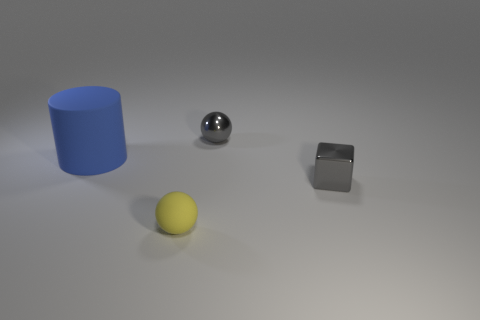What material is the thing that is both to the right of the yellow rubber ball and behind the gray cube?
Provide a short and direct response. Metal. What number of small gray metal things have the same shape as the blue matte thing?
Offer a terse response. 0. What is the sphere that is right of the small yellow thing made of?
Make the answer very short. Metal. Is the number of small gray objects to the right of the tiny yellow thing less than the number of tiny gray metallic objects?
Your response must be concise. No. Is the small matte object the same shape as the blue matte object?
Your response must be concise. No. Is there anything else that is the same shape as the blue object?
Ensure brevity in your answer.  No. Are there any purple cylinders?
Ensure brevity in your answer.  No. There is a tiny yellow thing; is it the same shape as the small gray thing behind the large blue matte thing?
Provide a short and direct response. Yes. There is a small yellow sphere that is in front of the ball that is behind the large cylinder; what is its material?
Make the answer very short. Rubber. The small rubber sphere has what color?
Offer a terse response. Yellow. 